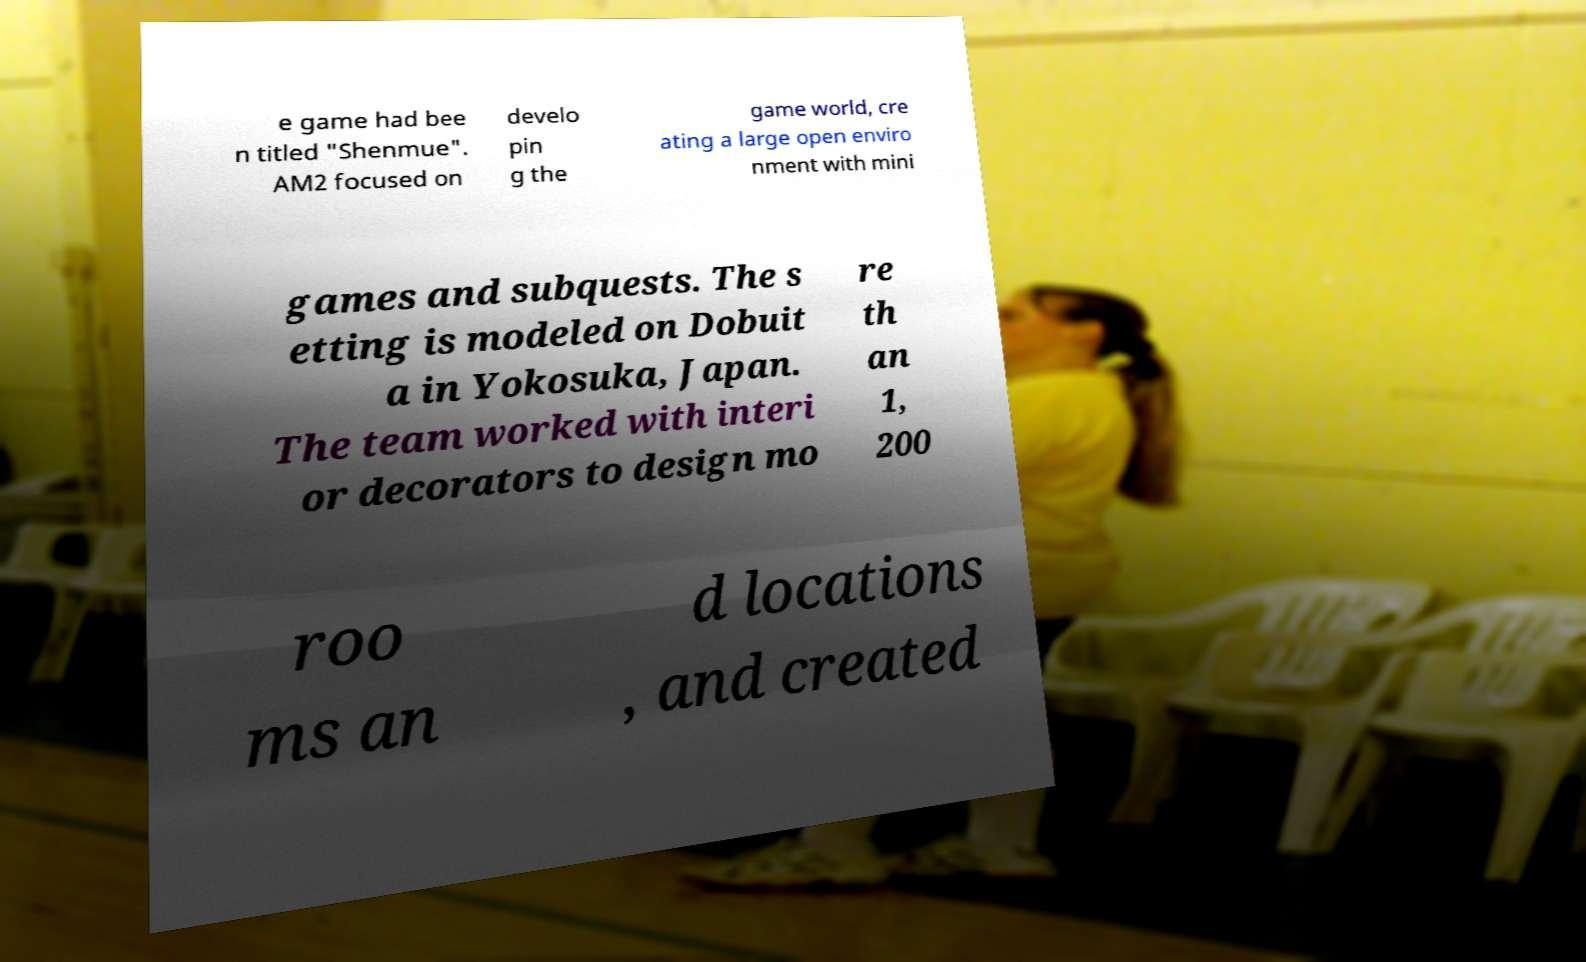There's text embedded in this image that I need extracted. Can you transcribe it verbatim? e game had bee n titled "Shenmue". AM2 focused on develo pin g the game world, cre ating a large open enviro nment with mini games and subquests. The s etting is modeled on Dobuit a in Yokosuka, Japan. The team worked with interi or decorators to design mo re th an 1, 200 roo ms an d locations , and created 